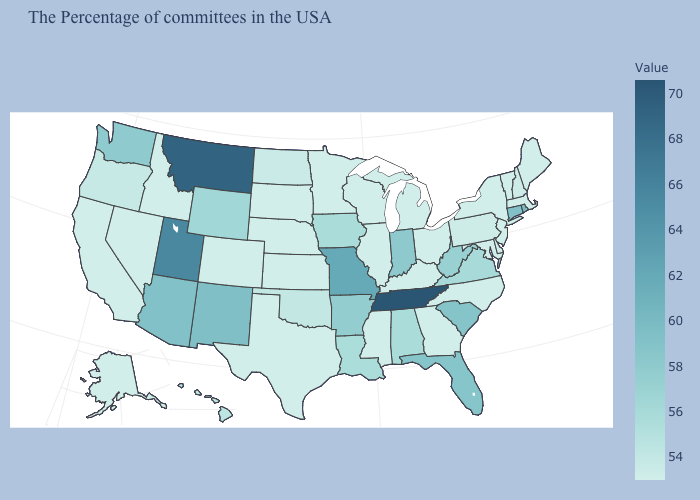Does Tennessee have the highest value in the South?
Answer briefly. Yes. Which states hav the highest value in the West?
Give a very brief answer. Montana. Among the states that border Massachusetts , does Vermont have the highest value?
Be succinct. No. Which states have the lowest value in the USA?
Short answer required. Maine, Massachusetts, Vermont, New York, New Jersey, Delaware, Maryland, North Carolina, Ohio, Georgia, Michigan, Kentucky, Wisconsin, Illinois, Mississippi, Minnesota, Kansas, Nebraska, Texas, South Dakota, Colorado, Idaho, Nevada, California, Alaska. Among the states that border North Dakota , which have the highest value?
Short answer required. Montana. Does Delaware have the lowest value in the USA?
Concise answer only. Yes. Does New York have a higher value than Utah?
Short answer required. No. 